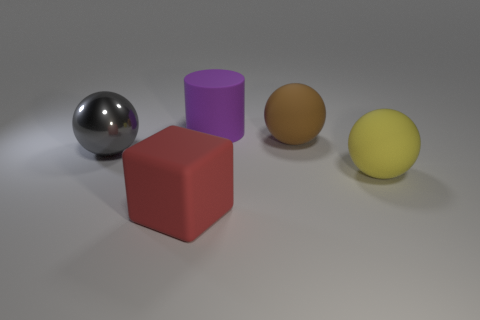Add 3 red rubber objects. How many objects exist? 8 Subtract all cylinders. How many objects are left? 4 Subtract all big yellow rubber objects. Subtract all purple cylinders. How many objects are left? 3 Add 4 big brown objects. How many big brown objects are left? 5 Add 4 big cyan matte cylinders. How many big cyan matte cylinders exist? 4 Subtract 1 yellow balls. How many objects are left? 4 